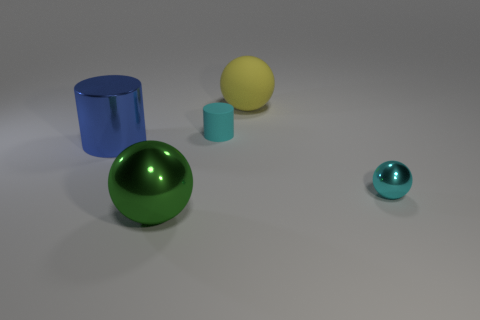Add 3 big green metallic spheres. How many objects exist? 8 Subtract all cyan shiny spheres. How many spheres are left? 2 Subtract all cyan cylinders. How many cylinders are left? 1 Subtract all cylinders. How many objects are left? 3 Subtract 1 cylinders. How many cylinders are left? 1 Add 1 brown rubber cylinders. How many brown rubber cylinders exist? 1 Subtract 1 yellow balls. How many objects are left? 4 Subtract all cyan cylinders. Subtract all green blocks. How many cylinders are left? 1 Subtract all cyan cylinders. How many purple spheres are left? 0 Subtract all metal spheres. Subtract all tiny rubber objects. How many objects are left? 2 